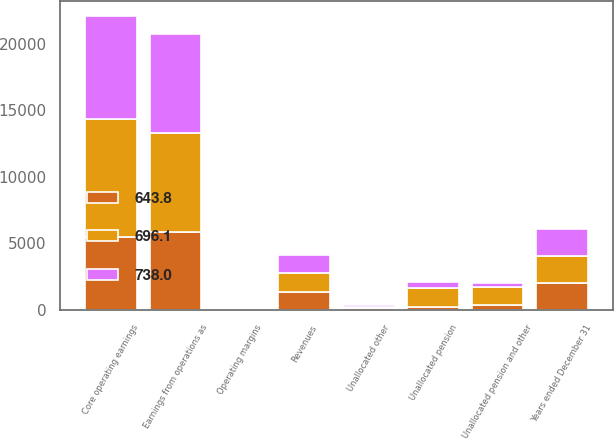<chart> <loc_0><loc_0><loc_500><loc_500><stacked_bar_chart><ecel><fcel>Years ended December 31<fcel>Revenues<fcel>Earnings from operations as<fcel>Operating margins<fcel>Unallocated pension<fcel>Unallocated other<fcel>Unallocated pension and other<fcel>Core operating earnings<nl><fcel>643.8<fcel>2016<fcel>1387<fcel>5834<fcel>6.2<fcel>217<fcel>153<fcel>370<fcel>5464<nl><fcel>738<fcel>2015<fcel>1387<fcel>7443<fcel>7.7<fcel>421<fcel>123<fcel>298<fcel>7741<nl><fcel>696.1<fcel>2014<fcel>1387<fcel>7473<fcel>8.2<fcel>1469<fcel>82<fcel>1387<fcel>8860<nl></chart> 